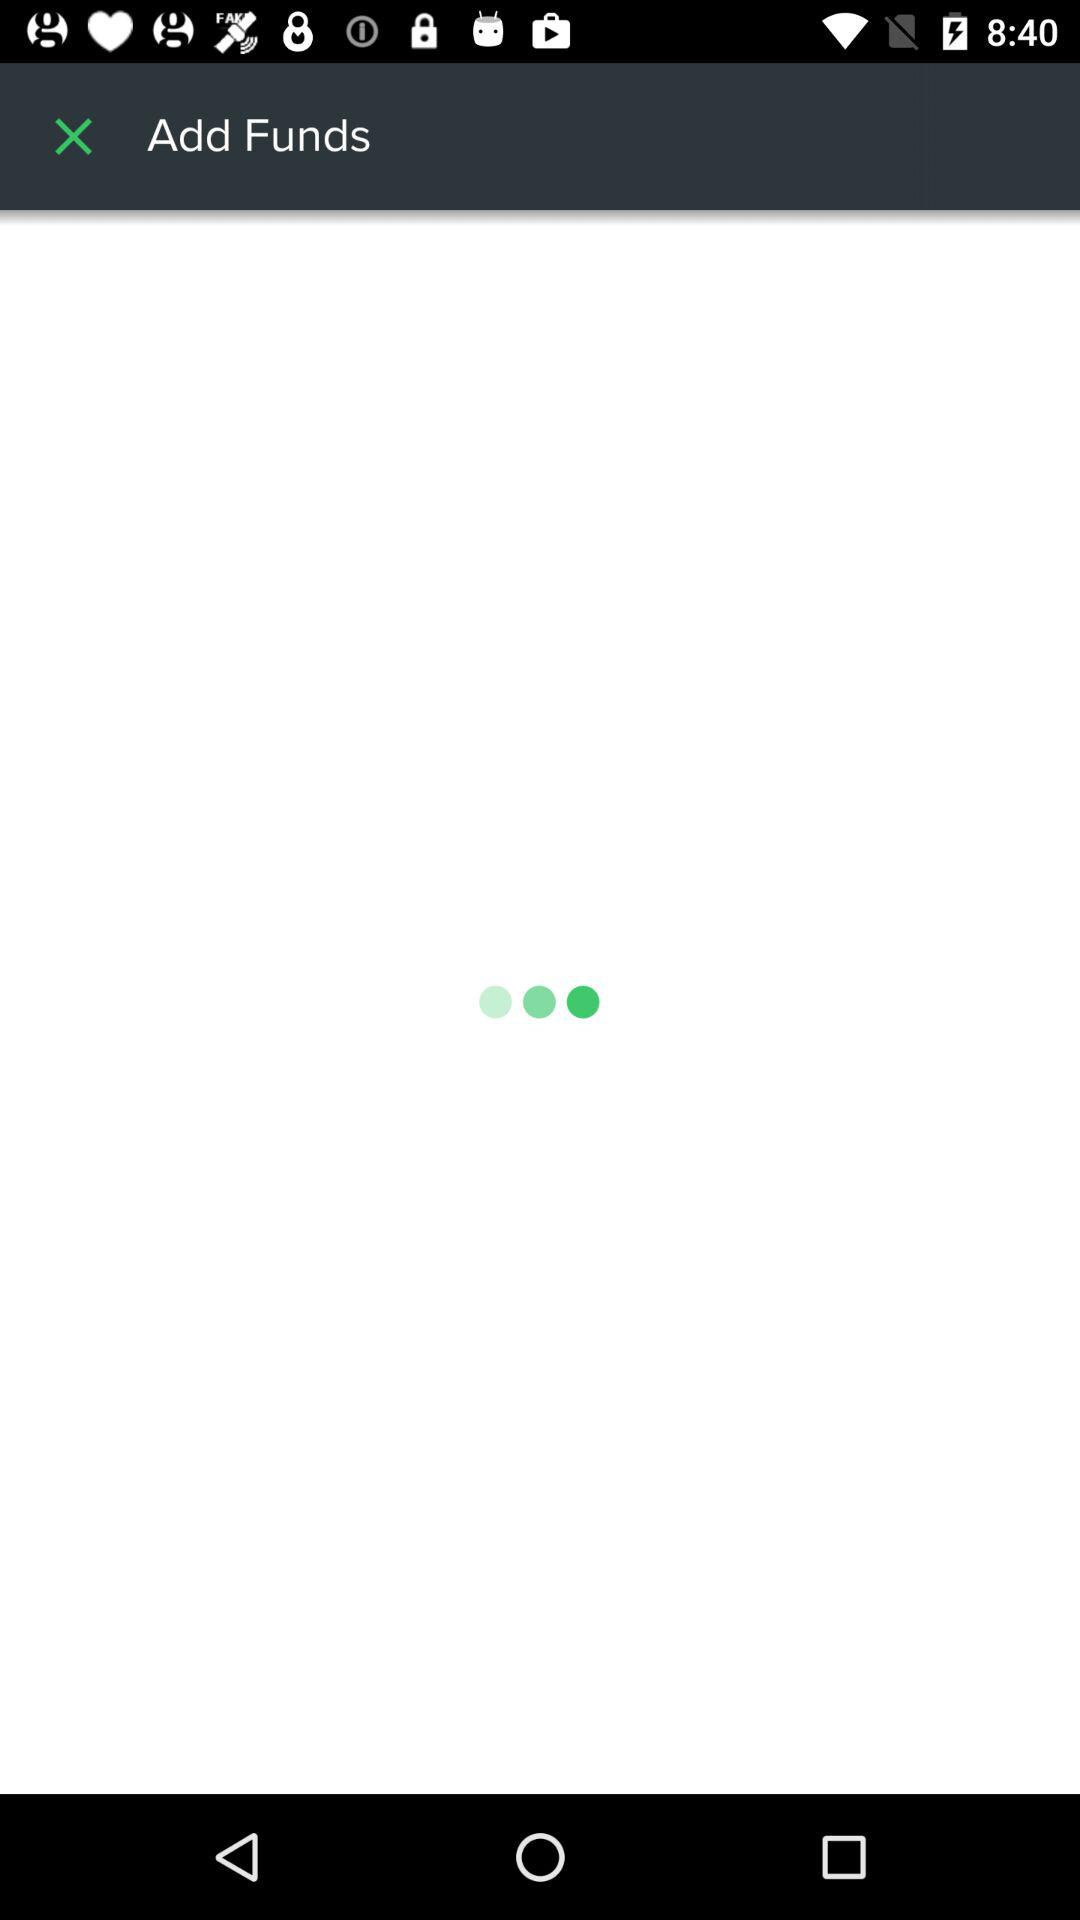What is the entered password? The entered password is "appcrawler3116". 